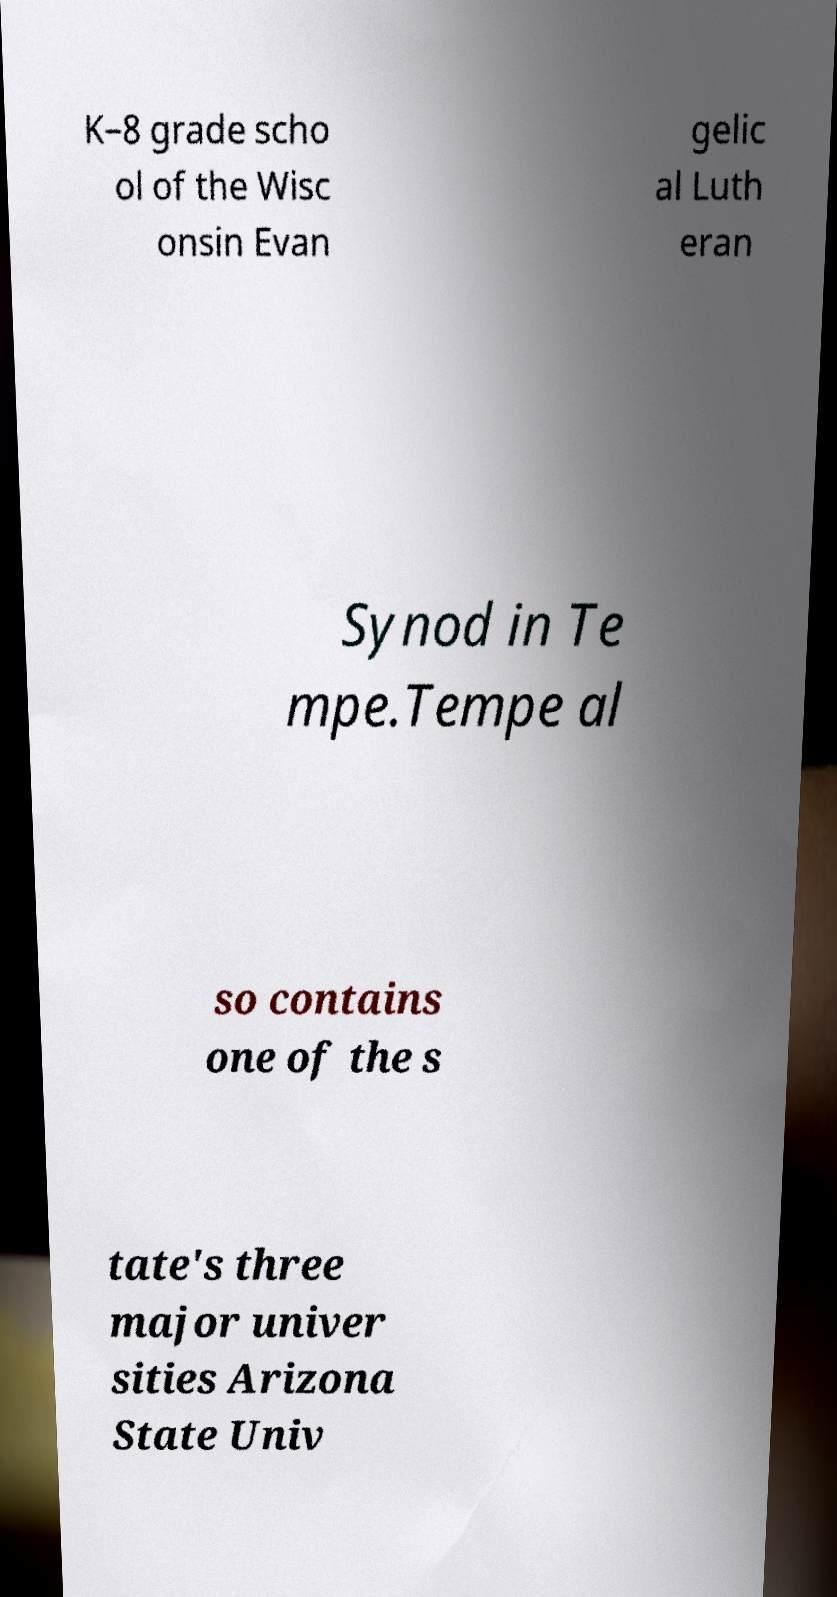Could you assist in decoding the text presented in this image and type it out clearly? K–8 grade scho ol of the Wisc onsin Evan gelic al Luth eran Synod in Te mpe.Tempe al so contains one of the s tate's three major univer sities Arizona State Univ 